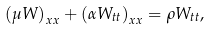<formula> <loc_0><loc_0><loc_500><loc_500>\left ( \mu W \right ) _ { x x } + \left ( \alpha W _ { t t } \right ) _ { x x } = \rho W _ { t t } ,</formula> 